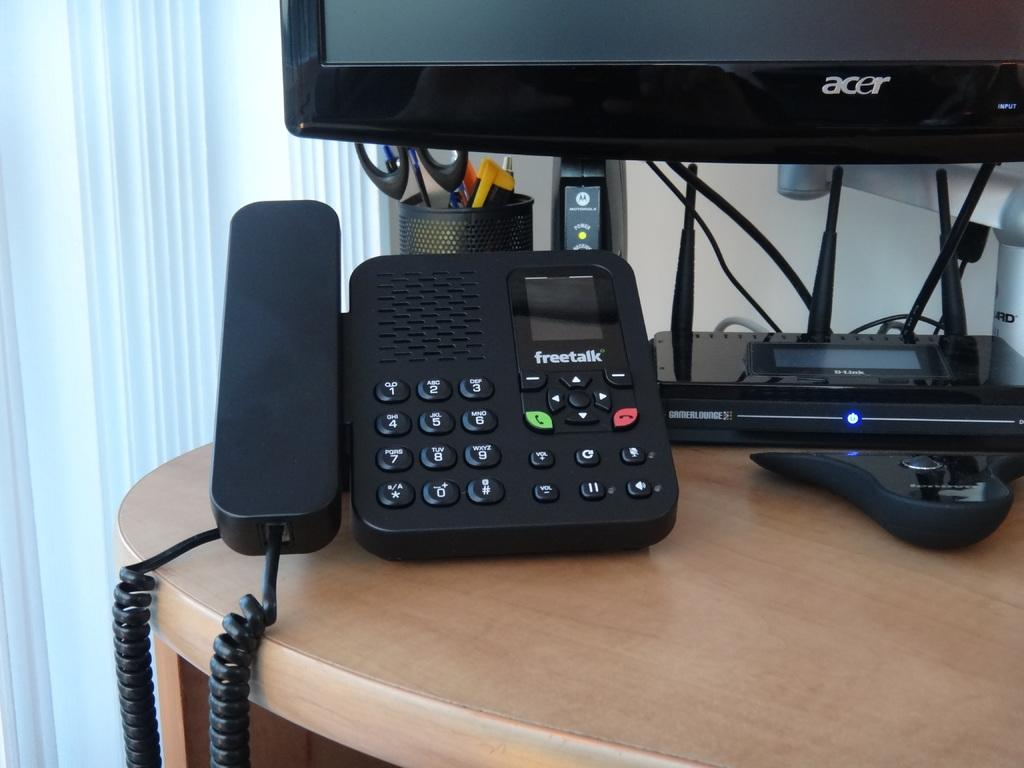What type of communication device is visible in the image? There is a telephone in the image. What electronic device is also present in the image? There is a monitor in the image. What device is used for connecting to the internet in the image? There is a router in the image. What is used for holding pens or pencils in the image? There is a pen holder in the image. What other items can be seen on the table in the image? There are other things on the table, but their specific details are not mentioned in the provided facts. What type of window covering is beside the table in the image? There are window blinds beside the table in the image. What type of cloud is visible through the window in the image? There is no mention of a window or a cloud in the provided facts, so it cannot be determined from the image. Who is the servant attending to in the image? There is no servant or person being attended to in the image. 